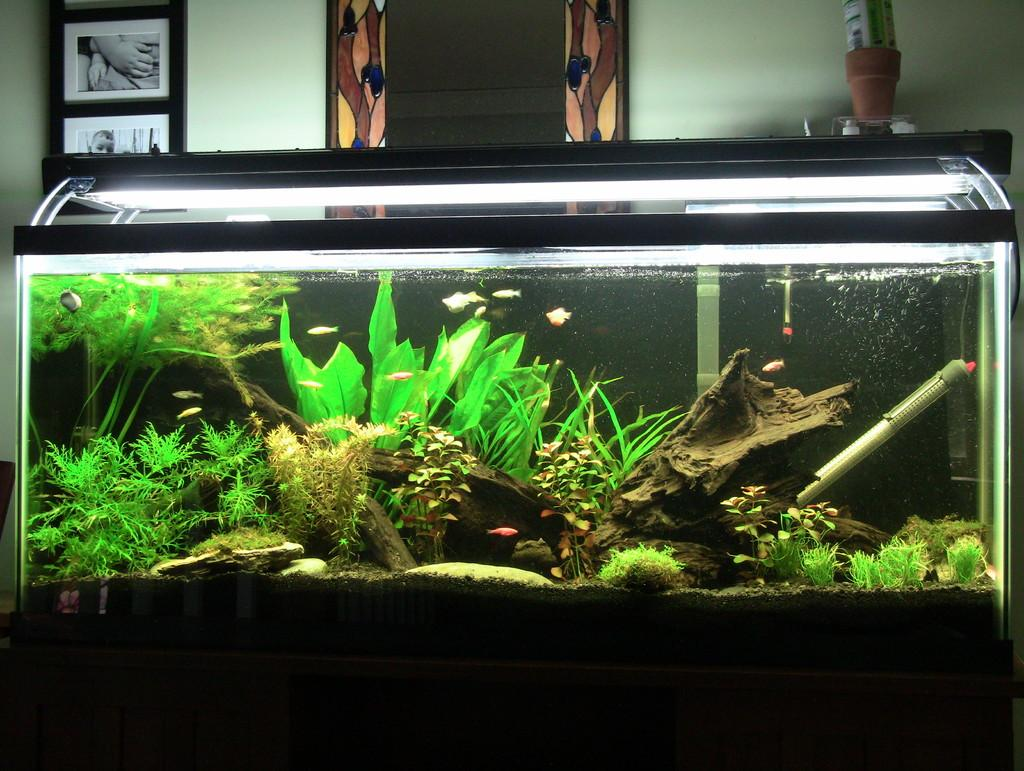What is the main subject of the image? There is an aquarium in the image. What can be found inside the aquarium? The aquarium contains fishes and other objects. What can be seen in the background of the image? There are photo frames and other objects in the background of the image. Can you see a pin holding a note in the image? There is no pin or note visible in the image. Is there a crow perched on the edge of the aquarium in the image? There is no crow present in the image. 